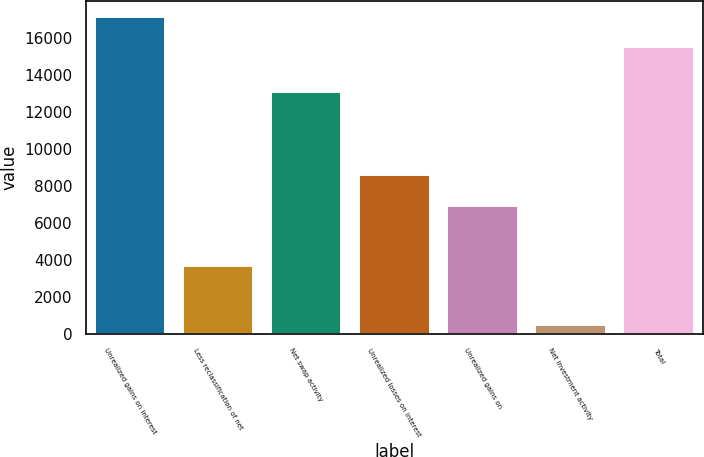Convert chart. <chart><loc_0><loc_0><loc_500><loc_500><bar_chart><fcel>Unrealized gains on interest<fcel>Less reclassification of net<fcel>Net swap activity<fcel>Unrealized losses on interest<fcel>Unrealized gains on<fcel>Net investment activity<fcel>Total<nl><fcel>17138.2<fcel>3692<fcel>13076<fcel>8582.6<fcel>6952.4<fcel>519<fcel>15508<nl></chart> 